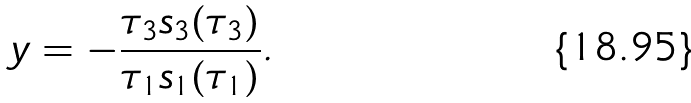Convert formula to latex. <formula><loc_0><loc_0><loc_500><loc_500>y = - \frac { \tau _ { 3 } s _ { 3 } ( \tau _ { 3 } ) } { \tau _ { 1 } s _ { 1 } ( \tau _ { 1 } ) } .</formula> 